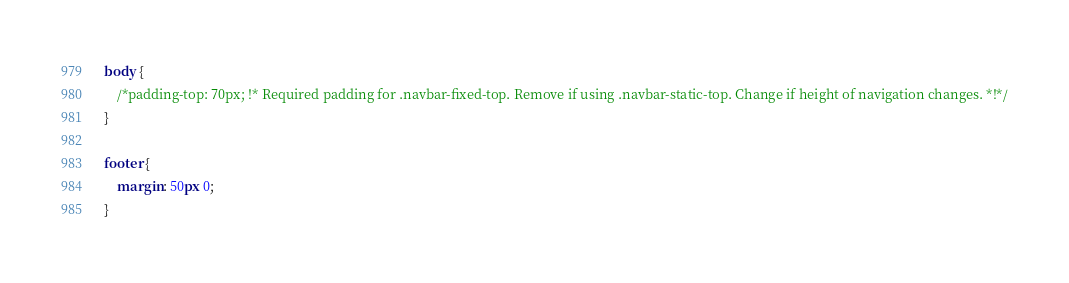<code> <loc_0><loc_0><loc_500><loc_500><_CSS_>body {
    /*padding-top: 70px; !* Required padding for .navbar-fixed-top. Remove if using .navbar-static-top. Change if height of navigation changes. *!*/
}

footer {
    margin: 50px 0;
}</code> 